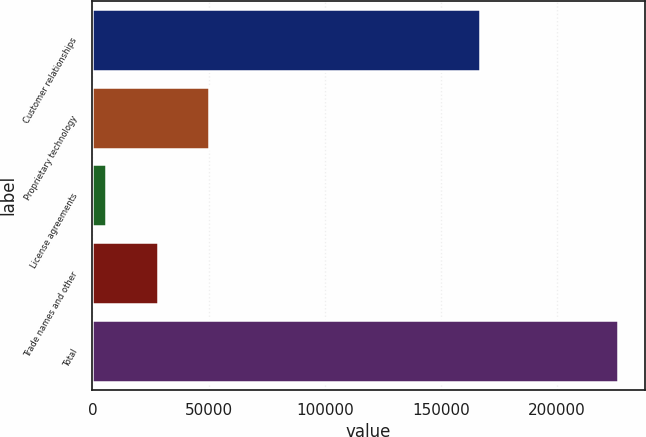<chart> <loc_0><loc_0><loc_500><loc_500><bar_chart><fcel>Customer relationships<fcel>Proprietary technology<fcel>License agreements<fcel>Trade names and other<fcel>Total<nl><fcel>166800<fcel>50080<fcel>6000<fcel>28040<fcel>226400<nl></chart> 